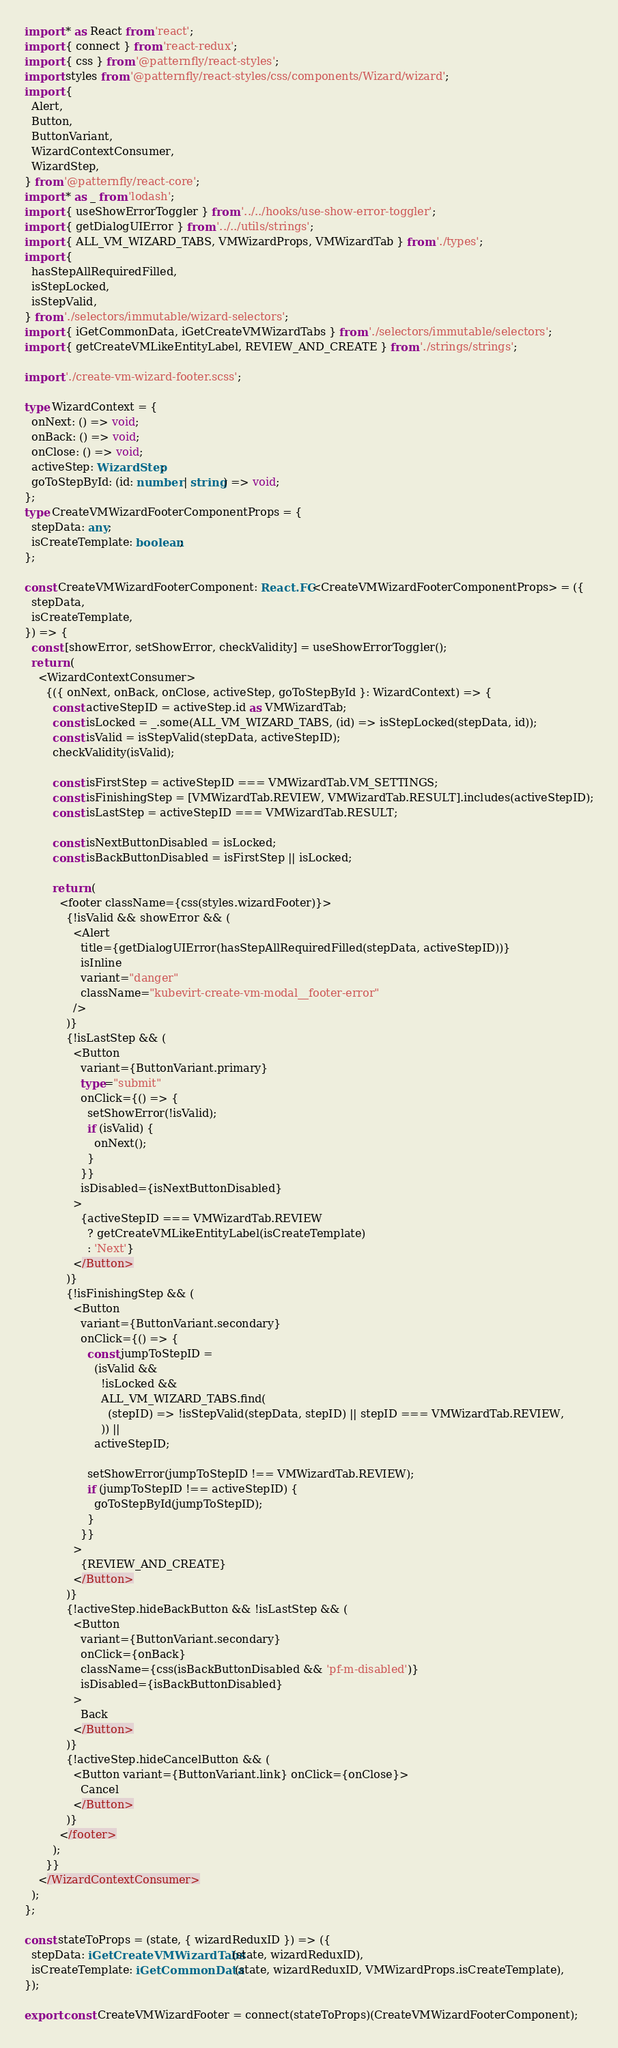Convert code to text. <code><loc_0><loc_0><loc_500><loc_500><_TypeScript_>import * as React from 'react';
import { connect } from 'react-redux';
import { css } from '@patternfly/react-styles';
import styles from '@patternfly/react-styles/css/components/Wizard/wizard';
import {
  Alert,
  Button,
  ButtonVariant,
  WizardContextConsumer,
  WizardStep,
} from '@patternfly/react-core';
import * as _ from 'lodash';
import { useShowErrorToggler } from '../../hooks/use-show-error-toggler';
import { getDialogUIError } from '../../utils/strings';
import { ALL_VM_WIZARD_TABS, VMWizardProps, VMWizardTab } from './types';
import {
  hasStepAllRequiredFilled,
  isStepLocked,
  isStepValid,
} from './selectors/immutable/wizard-selectors';
import { iGetCommonData, iGetCreateVMWizardTabs } from './selectors/immutable/selectors';
import { getCreateVMLikeEntityLabel, REVIEW_AND_CREATE } from './strings/strings';

import './create-vm-wizard-footer.scss';

type WizardContext = {
  onNext: () => void;
  onBack: () => void;
  onClose: () => void;
  activeStep: WizardStep;
  goToStepById: (id: number | string) => void;
};
type CreateVMWizardFooterComponentProps = {
  stepData: any;
  isCreateTemplate: boolean;
};

const CreateVMWizardFooterComponent: React.FC<CreateVMWizardFooterComponentProps> = ({
  stepData,
  isCreateTemplate,
}) => {
  const [showError, setShowError, checkValidity] = useShowErrorToggler();
  return (
    <WizardContextConsumer>
      {({ onNext, onBack, onClose, activeStep, goToStepById }: WizardContext) => {
        const activeStepID = activeStep.id as VMWizardTab;
        const isLocked = _.some(ALL_VM_WIZARD_TABS, (id) => isStepLocked(stepData, id));
        const isValid = isStepValid(stepData, activeStepID);
        checkValidity(isValid);

        const isFirstStep = activeStepID === VMWizardTab.VM_SETTINGS;
        const isFinishingStep = [VMWizardTab.REVIEW, VMWizardTab.RESULT].includes(activeStepID);
        const isLastStep = activeStepID === VMWizardTab.RESULT;

        const isNextButtonDisabled = isLocked;
        const isBackButtonDisabled = isFirstStep || isLocked;

        return (
          <footer className={css(styles.wizardFooter)}>
            {!isValid && showError && (
              <Alert
                title={getDialogUIError(hasStepAllRequiredFilled(stepData, activeStepID))}
                isInline
                variant="danger"
                className="kubevirt-create-vm-modal__footer-error"
              />
            )}
            {!isLastStep && (
              <Button
                variant={ButtonVariant.primary}
                type="submit"
                onClick={() => {
                  setShowError(!isValid);
                  if (isValid) {
                    onNext();
                  }
                }}
                isDisabled={isNextButtonDisabled}
              >
                {activeStepID === VMWizardTab.REVIEW
                  ? getCreateVMLikeEntityLabel(isCreateTemplate)
                  : 'Next'}
              </Button>
            )}
            {!isFinishingStep && (
              <Button
                variant={ButtonVariant.secondary}
                onClick={() => {
                  const jumpToStepID =
                    (isValid &&
                      !isLocked &&
                      ALL_VM_WIZARD_TABS.find(
                        (stepID) => !isStepValid(stepData, stepID) || stepID === VMWizardTab.REVIEW,
                      )) ||
                    activeStepID;

                  setShowError(jumpToStepID !== VMWizardTab.REVIEW);
                  if (jumpToStepID !== activeStepID) {
                    goToStepById(jumpToStepID);
                  }
                }}
              >
                {REVIEW_AND_CREATE}
              </Button>
            )}
            {!activeStep.hideBackButton && !isLastStep && (
              <Button
                variant={ButtonVariant.secondary}
                onClick={onBack}
                className={css(isBackButtonDisabled && 'pf-m-disabled')}
                isDisabled={isBackButtonDisabled}
              >
                Back
              </Button>
            )}
            {!activeStep.hideCancelButton && (
              <Button variant={ButtonVariant.link} onClick={onClose}>
                Cancel
              </Button>
            )}
          </footer>
        );
      }}
    </WizardContextConsumer>
  );
};

const stateToProps = (state, { wizardReduxID }) => ({
  stepData: iGetCreateVMWizardTabs(state, wizardReduxID),
  isCreateTemplate: iGetCommonData(state, wizardReduxID, VMWizardProps.isCreateTemplate),
});

export const CreateVMWizardFooter = connect(stateToProps)(CreateVMWizardFooterComponent);
</code> 